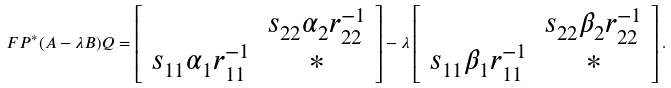Convert formula to latex. <formula><loc_0><loc_0><loc_500><loc_500>F P ^ { * } ( A - \lambda B ) Q = \left [ \begin{array} { c c } & s _ { 2 2 } \alpha _ { 2 } r _ { 2 2 } ^ { - 1 } \\ s _ { 1 1 } \alpha _ { 1 } r _ { 1 1 } ^ { - 1 } & { * } \end{array} \right ] - \lambda \left [ \begin{array} { c c } & s _ { 2 2 } \beta _ { 2 } r _ { 2 2 } ^ { - 1 } \\ s _ { 1 1 } \beta _ { 1 } r _ { 1 1 } ^ { - 1 } & { * } \end{array} \right ] .</formula> 